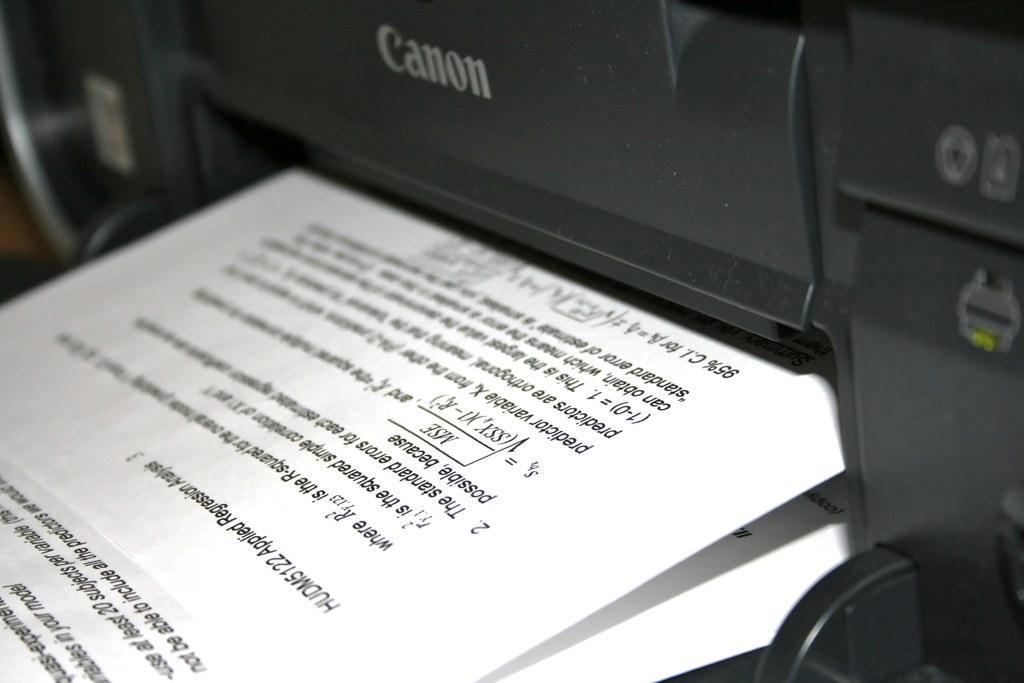Please provide a concise description of this image. In this picture we can see a printing machine and papers. In the papers we can see the text. 